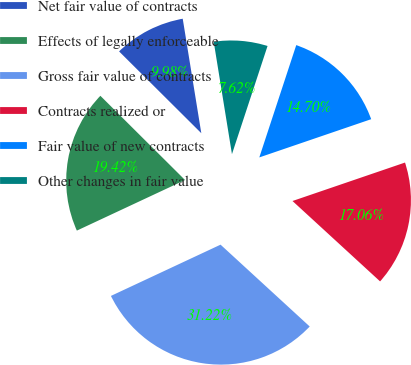<chart> <loc_0><loc_0><loc_500><loc_500><pie_chart><fcel>Net fair value of contracts<fcel>Effects of legally enforceable<fcel>Gross fair value of contracts<fcel>Contracts realized or<fcel>Fair value of new contracts<fcel>Other changes in fair value<nl><fcel>9.98%<fcel>19.42%<fcel>31.22%<fcel>17.06%<fcel>14.7%<fcel>7.62%<nl></chart> 